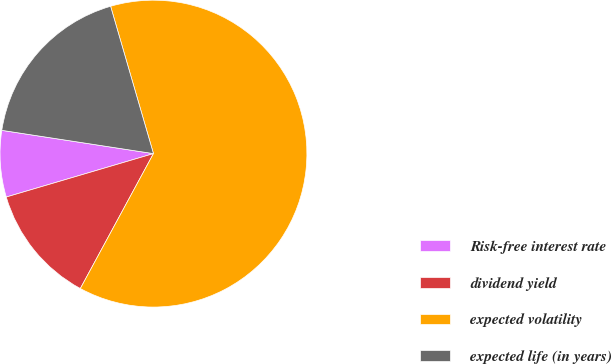Convert chart. <chart><loc_0><loc_0><loc_500><loc_500><pie_chart><fcel>Risk-free interest rate<fcel>dividend yield<fcel>expected volatility<fcel>expected life (in years)<nl><fcel>6.99%<fcel>12.53%<fcel>62.41%<fcel>18.07%<nl></chart> 